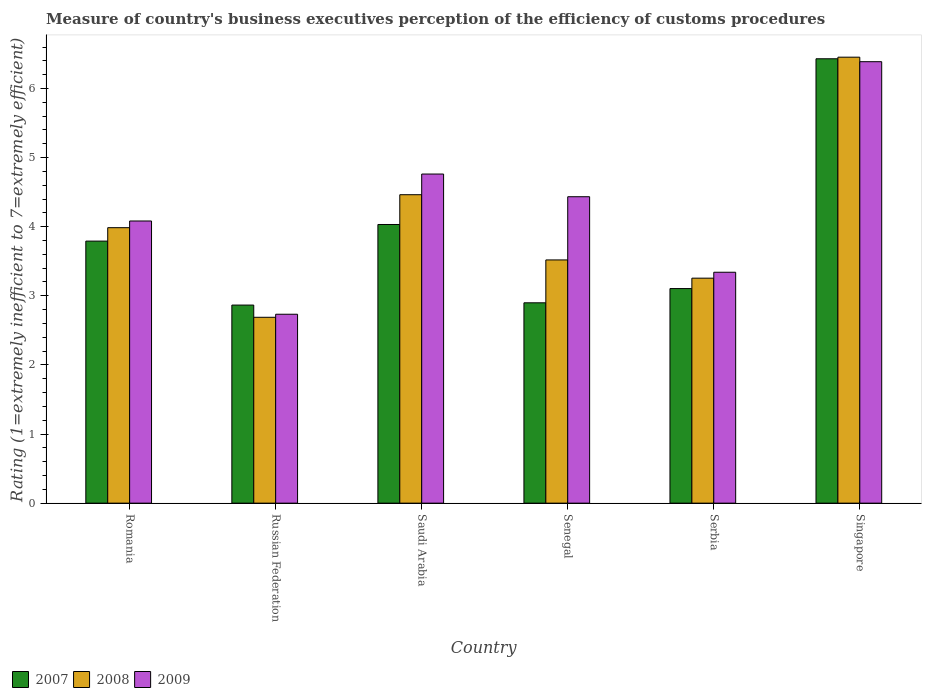Are the number of bars on each tick of the X-axis equal?
Ensure brevity in your answer.  Yes. How many bars are there on the 6th tick from the left?
Offer a very short reply. 3. What is the label of the 6th group of bars from the left?
Ensure brevity in your answer.  Singapore. In how many cases, is the number of bars for a given country not equal to the number of legend labels?
Your answer should be compact. 0. What is the rating of the efficiency of customs procedure in 2009 in Russian Federation?
Ensure brevity in your answer.  2.73. Across all countries, what is the maximum rating of the efficiency of customs procedure in 2008?
Make the answer very short. 6.45. Across all countries, what is the minimum rating of the efficiency of customs procedure in 2007?
Make the answer very short. 2.87. In which country was the rating of the efficiency of customs procedure in 2009 maximum?
Keep it short and to the point. Singapore. In which country was the rating of the efficiency of customs procedure in 2009 minimum?
Keep it short and to the point. Russian Federation. What is the total rating of the efficiency of customs procedure in 2007 in the graph?
Keep it short and to the point. 23.12. What is the difference between the rating of the efficiency of customs procedure in 2007 in Saudi Arabia and that in Senegal?
Provide a succinct answer. 1.13. What is the difference between the rating of the efficiency of customs procedure in 2008 in Romania and the rating of the efficiency of customs procedure in 2009 in Singapore?
Provide a short and direct response. -2.4. What is the average rating of the efficiency of customs procedure in 2007 per country?
Make the answer very short. 3.85. What is the difference between the rating of the efficiency of customs procedure of/in 2009 and rating of the efficiency of customs procedure of/in 2008 in Serbia?
Ensure brevity in your answer.  0.09. What is the ratio of the rating of the efficiency of customs procedure in 2009 in Russian Federation to that in Serbia?
Your answer should be compact. 0.82. Is the rating of the efficiency of customs procedure in 2009 in Romania less than that in Senegal?
Your answer should be very brief. Yes. Is the difference between the rating of the efficiency of customs procedure in 2009 in Senegal and Serbia greater than the difference between the rating of the efficiency of customs procedure in 2008 in Senegal and Serbia?
Offer a terse response. Yes. What is the difference between the highest and the second highest rating of the efficiency of customs procedure in 2009?
Offer a terse response. 0.33. What is the difference between the highest and the lowest rating of the efficiency of customs procedure in 2007?
Make the answer very short. 3.56. Is the sum of the rating of the efficiency of customs procedure in 2007 in Saudi Arabia and Senegal greater than the maximum rating of the efficiency of customs procedure in 2008 across all countries?
Your answer should be compact. Yes. Is it the case that in every country, the sum of the rating of the efficiency of customs procedure in 2008 and rating of the efficiency of customs procedure in 2009 is greater than the rating of the efficiency of customs procedure in 2007?
Ensure brevity in your answer.  Yes. How many bars are there?
Your response must be concise. 18. What is the difference between two consecutive major ticks on the Y-axis?
Your answer should be compact. 1. Are the values on the major ticks of Y-axis written in scientific E-notation?
Provide a short and direct response. No. Does the graph contain grids?
Make the answer very short. No. How many legend labels are there?
Your answer should be compact. 3. What is the title of the graph?
Offer a terse response. Measure of country's business executives perception of the efficiency of customs procedures. Does "1991" appear as one of the legend labels in the graph?
Provide a short and direct response. No. What is the label or title of the Y-axis?
Provide a succinct answer. Rating (1=extremely inefficient to 7=extremely efficient). What is the Rating (1=extremely inefficient to 7=extremely efficient) of 2007 in Romania?
Offer a terse response. 3.79. What is the Rating (1=extremely inefficient to 7=extremely efficient) of 2008 in Romania?
Keep it short and to the point. 3.99. What is the Rating (1=extremely inefficient to 7=extremely efficient) of 2009 in Romania?
Your answer should be compact. 4.08. What is the Rating (1=extremely inefficient to 7=extremely efficient) of 2007 in Russian Federation?
Your answer should be compact. 2.87. What is the Rating (1=extremely inefficient to 7=extremely efficient) in 2008 in Russian Federation?
Keep it short and to the point. 2.69. What is the Rating (1=extremely inefficient to 7=extremely efficient) in 2009 in Russian Federation?
Your answer should be compact. 2.73. What is the Rating (1=extremely inefficient to 7=extremely efficient) of 2007 in Saudi Arabia?
Your response must be concise. 4.03. What is the Rating (1=extremely inefficient to 7=extremely efficient) in 2008 in Saudi Arabia?
Your response must be concise. 4.46. What is the Rating (1=extremely inefficient to 7=extremely efficient) in 2009 in Saudi Arabia?
Give a very brief answer. 4.76. What is the Rating (1=extremely inefficient to 7=extremely efficient) in 2007 in Senegal?
Make the answer very short. 2.9. What is the Rating (1=extremely inefficient to 7=extremely efficient) of 2008 in Senegal?
Ensure brevity in your answer.  3.52. What is the Rating (1=extremely inefficient to 7=extremely efficient) of 2009 in Senegal?
Offer a terse response. 4.43. What is the Rating (1=extremely inefficient to 7=extremely efficient) in 2007 in Serbia?
Provide a succinct answer. 3.1. What is the Rating (1=extremely inefficient to 7=extremely efficient) of 2008 in Serbia?
Provide a short and direct response. 3.26. What is the Rating (1=extremely inefficient to 7=extremely efficient) in 2009 in Serbia?
Your answer should be compact. 3.34. What is the Rating (1=extremely inefficient to 7=extremely efficient) of 2007 in Singapore?
Give a very brief answer. 6.43. What is the Rating (1=extremely inefficient to 7=extremely efficient) of 2008 in Singapore?
Make the answer very short. 6.45. What is the Rating (1=extremely inefficient to 7=extremely efficient) in 2009 in Singapore?
Your response must be concise. 6.39. Across all countries, what is the maximum Rating (1=extremely inefficient to 7=extremely efficient) of 2007?
Provide a succinct answer. 6.43. Across all countries, what is the maximum Rating (1=extremely inefficient to 7=extremely efficient) in 2008?
Ensure brevity in your answer.  6.45. Across all countries, what is the maximum Rating (1=extremely inefficient to 7=extremely efficient) in 2009?
Provide a short and direct response. 6.39. Across all countries, what is the minimum Rating (1=extremely inefficient to 7=extremely efficient) in 2007?
Provide a short and direct response. 2.87. Across all countries, what is the minimum Rating (1=extremely inefficient to 7=extremely efficient) of 2008?
Your response must be concise. 2.69. Across all countries, what is the minimum Rating (1=extremely inefficient to 7=extremely efficient) of 2009?
Offer a terse response. 2.73. What is the total Rating (1=extremely inefficient to 7=extremely efficient) of 2007 in the graph?
Give a very brief answer. 23.12. What is the total Rating (1=extremely inefficient to 7=extremely efficient) in 2008 in the graph?
Your answer should be compact. 24.37. What is the total Rating (1=extremely inefficient to 7=extremely efficient) of 2009 in the graph?
Provide a succinct answer. 25.74. What is the difference between the Rating (1=extremely inefficient to 7=extremely efficient) of 2007 in Romania and that in Russian Federation?
Your answer should be compact. 0.93. What is the difference between the Rating (1=extremely inefficient to 7=extremely efficient) of 2008 in Romania and that in Russian Federation?
Your answer should be compact. 1.3. What is the difference between the Rating (1=extremely inefficient to 7=extremely efficient) of 2009 in Romania and that in Russian Federation?
Provide a short and direct response. 1.35. What is the difference between the Rating (1=extremely inefficient to 7=extremely efficient) of 2007 in Romania and that in Saudi Arabia?
Keep it short and to the point. -0.24. What is the difference between the Rating (1=extremely inefficient to 7=extremely efficient) of 2008 in Romania and that in Saudi Arabia?
Give a very brief answer. -0.48. What is the difference between the Rating (1=extremely inefficient to 7=extremely efficient) in 2009 in Romania and that in Saudi Arabia?
Make the answer very short. -0.68. What is the difference between the Rating (1=extremely inefficient to 7=extremely efficient) of 2007 in Romania and that in Senegal?
Your answer should be compact. 0.89. What is the difference between the Rating (1=extremely inefficient to 7=extremely efficient) of 2008 in Romania and that in Senegal?
Offer a very short reply. 0.47. What is the difference between the Rating (1=extremely inefficient to 7=extremely efficient) of 2009 in Romania and that in Senegal?
Your response must be concise. -0.35. What is the difference between the Rating (1=extremely inefficient to 7=extremely efficient) of 2007 in Romania and that in Serbia?
Make the answer very short. 0.69. What is the difference between the Rating (1=extremely inefficient to 7=extremely efficient) in 2008 in Romania and that in Serbia?
Offer a very short reply. 0.73. What is the difference between the Rating (1=extremely inefficient to 7=extremely efficient) of 2009 in Romania and that in Serbia?
Your answer should be compact. 0.74. What is the difference between the Rating (1=extremely inefficient to 7=extremely efficient) of 2007 in Romania and that in Singapore?
Ensure brevity in your answer.  -2.64. What is the difference between the Rating (1=extremely inefficient to 7=extremely efficient) in 2008 in Romania and that in Singapore?
Provide a short and direct response. -2.47. What is the difference between the Rating (1=extremely inefficient to 7=extremely efficient) in 2009 in Romania and that in Singapore?
Keep it short and to the point. -2.3. What is the difference between the Rating (1=extremely inefficient to 7=extremely efficient) in 2007 in Russian Federation and that in Saudi Arabia?
Your answer should be very brief. -1.17. What is the difference between the Rating (1=extremely inefficient to 7=extremely efficient) of 2008 in Russian Federation and that in Saudi Arabia?
Keep it short and to the point. -1.77. What is the difference between the Rating (1=extremely inefficient to 7=extremely efficient) of 2009 in Russian Federation and that in Saudi Arabia?
Provide a short and direct response. -2.03. What is the difference between the Rating (1=extremely inefficient to 7=extremely efficient) in 2007 in Russian Federation and that in Senegal?
Your answer should be very brief. -0.03. What is the difference between the Rating (1=extremely inefficient to 7=extremely efficient) of 2008 in Russian Federation and that in Senegal?
Your answer should be very brief. -0.83. What is the difference between the Rating (1=extremely inefficient to 7=extremely efficient) in 2009 in Russian Federation and that in Senegal?
Your answer should be very brief. -1.7. What is the difference between the Rating (1=extremely inefficient to 7=extremely efficient) in 2007 in Russian Federation and that in Serbia?
Offer a very short reply. -0.24. What is the difference between the Rating (1=extremely inefficient to 7=extremely efficient) in 2008 in Russian Federation and that in Serbia?
Give a very brief answer. -0.57. What is the difference between the Rating (1=extremely inefficient to 7=extremely efficient) in 2009 in Russian Federation and that in Serbia?
Offer a very short reply. -0.61. What is the difference between the Rating (1=extremely inefficient to 7=extremely efficient) in 2007 in Russian Federation and that in Singapore?
Provide a short and direct response. -3.56. What is the difference between the Rating (1=extremely inefficient to 7=extremely efficient) of 2008 in Russian Federation and that in Singapore?
Offer a very short reply. -3.76. What is the difference between the Rating (1=extremely inefficient to 7=extremely efficient) of 2009 in Russian Federation and that in Singapore?
Give a very brief answer. -3.65. What is the difference between the Rating (1=extremely inefficient to 7=extremely efficient) of 2007 in Saudi Arabia and that in Senegal?
Provide a short and direct response. 1.13. What is the difference between the Rating (1=extremely inefficient to 7=extremely efficient) of 2008 in Saudi Arabia and that in Senegal?
Provide a succinct answer. 0.94. What is the difference between the Rating (1=extremely inefficient to 7=extremely efficient) in 2009 in Saudi Arabia and that in Senegal?
Your answer should be very brief. 0.33. What is the difference between the Rating (1=extremely inefficient to 7=extremely efficient) of 2007 in Saudi Arabia and that in Serbia?
Provide a succinct answer. 0.93. What is the difference between the Rating (1=extremely inefficient to 7=extremely efficient) in 2008 in Saudi Arabia and that in Serbia?
Keep it short and to the point. 1.21. What is the difference between the Rating (1=extremely inefficient to 7=extremely efficient) in 2009 in Saudi Arabia and that in Serbia?
Provide a succinct answer. 1.42. What is the difference between the Rating (1=extremely inefficient to 7=extremely efficient) of 2007 in Saudi Arabia and that in Singapore?
Make the answer very short. -2.4. What is the difference between the Rating (1=extremely inefficient to 7=extremely efficient) in 2008 in Saudi Arabia and that in Singapore?
Provide a short and direct response. -1.99. What is the difference between the Rating (1=extremely inefficient to 7=extremely efficient) of 2009 in Saudi Arabia and that in Singapore?
Your answer should be compact. -1.63. What is the difference between the Rating (1=extremely inefficient to 7=extremely efficient) of 2007 in Senegal and that in Serbia?
Ensure brevity in your answer.  -0.21. What is the difference between the Rating (1=extremely inefficient to 7=extremely efficient) of 2008 in Senegal and that in Serbia?
Provide a succinct answer. 0.26. What is the difference between the Rating (1=extremely inefficient to 7=extremely efficient) of 2009 in Senegal and that in Serbia?
Your answer should be compact. 1.09. What is the difference between the Rating (1=extremely inefficient to 7=extremely efficient) in 2007 in Senegal and that in Singapore?
Your response must be concise. -3.53. What is the difference between the Rating (1=extremely inefficient to 7=extremely efficient) in 2008 in Senegal and that in Singapore?
Provide a short and direct response. -2.93. What is the difference between the Rating (1=extremely inefficient to 7=extremely efficient) of 2009 in Senegal and that in Singapore?
Ensure brevity in your answer.  -1.95. What is the difference between the Rating (1=extremely inefficient to 7=extremely efficient) in 2007 in Serbia and that in Singapore?
Make the answer very short. -3.33. What is the difference between the Rating (1=extremely inefficient to 7=extremely efficient) in 2008 in Serbia and that in Singapore?
Provide a short and direct response. -3.2. What is the difference between the Rating (1=extremely inefficient to 7=extremely efficient) of 2009 in Serbia and that in Singapore?
Offer a very short reply. -3.05. What is the difference between the Rating (1=extremely inefficient to 7=extremely efficient) in 2007 in Romania and the Rating (1=extremely inefficient to 7=extremely efficient) in 2008 in Russian Federation?
Offer a very short reply. 1.1. What is the difference between the Rating (1=extremely inefficient to 7=extremely efficient) in 2007 in Romania and the Rating (1=extremely inefficient to 7=extremely efficient) in 2009 in Russian Federation?
Your response must be concise. 1.06. What is the difference between the Rating (1=extremely inefficient to 7=extremely efficient) in 2008 in Romania and the Rating (1=extremely inefficient to 7=extremely efficient) in 2009 in Russian Federation?
Keep it short and to the point. 1.25. What is the difference between the Rating (1=extremely inefficient to 7=extremely efficient) in 2007 in Romania and the Rating (1=extremely inefficient to 7=extremely efficient) in 2008 in Saudi Arabia?
Keep it short and to the point. -0.67. What is the difference between the Rating (1=extremely inefficient to 7=extremely efficient) in 2007 in Romania and the Rating (1=extremely inefficient to 7=extremely efficient) in 2009 in Saudi Arabia?
Give a very brief answer. -0.97. What is the difference between the Rating (1=extremely inefficient to 7=extremely efficient) of 2008 in Romania and the Rating (1=extremely inefficient to 7=extremely efficient) of 2009 in Saudi Arabia?
Ensure brevity in your answer.  -0.78. What is the difference between the Rating (1=extremely inefficient to 7=extremely efficient) of 2007 in Romania and the Rating (1=extremely inefficient to 7=extremely efficient) of 2008 in Senegal?
Keep it short and to the point. 0.27. What is the difference between the Rating (1=extremely inefficient to 7=extremely efficient) of 2007 in Romania and the Rating (1=extremely inefficient to 7=extremely efficient) of 2009 in Senegal?
Provide a succinct answer. -0.64. What is the difference between the Rating (1=extremely inefficient to 7=extremely efficient) of 2008 in Romania and the Rating (1=extremely inefficient to 7=extremely efficient) of 2009 in Senegal?
Offer a very short reply. -0.45. What is the difference between the Rating (1=extremely inefficient to 7=extremely efficient) in 2007 in Romania and the Rating (1=extremely inefficient to 7=extremely efficient) in 2008 in Serbia?
Offer a terse response. 0.54. What is the difference between the Rating (1=extremely inefficient to 7=extremely efficient) of 2007 in Romania and the Rating (1=extremely inefficient to 7=extremely efficient) of 2009 in Serbia?
Provide a succinct answer. 0.45. What is the difference between the Rating (1=extremely inefficient to 7=extremely efficient) in 2008 in Romania and the Rating (1=extremely inefficient to 7=extremely efficient) in 2009 in Serbia?
Offer a terse response. 0.64. What is the difference between the Rating (1=extremely inefficient to 7=extremely efficient) of 2007 in Romania and the Rating (1=extremely inefficient to 7=extremely efficient) of 2008 in Singapore?
Your response must be concise. -2.66. What is the difference between the Rating (1=extremely inefficient to 7=extremely efficient) in 2007 in Romania and the Rating (1=extremely inefficient to 7=extremely efficient) in 2009 in Singapore?
Keep it short and to the point. -2.6. What is the difference between the Rating (1=extremely inefficient to 7=extremely efficient) of 2008 in Romania and the Rating (1=extremely inefficient to 7=extremely efficient) of 2009 in Singapore?
Your response must be concise. -2.4. What is the difference between the Rating (1=extremely inefficient to 7=extremely efficient) in 2007 in Russian Federation and the Rating (1=extremely inefficient to 7=extremely efficient) in 2008 in Saudi Arabia?
Keep it short and to the point. -1.6. What is the difference between the Rating (1=extremely inefficient to 7=extremely efficient) of 2007 in Russian Federation and the Rating (1=extremely inefficient to 7=extremely efficient) of 2009 in Saudi Arabia?
Your answer should be very brief. -1.9. What is the difference between the Rating (1=extremely inefficient to 7=extremely efficient) of 2008 in Russian Federation and the Rating (1=extremely inefficient to 7=extremely efficient) of 2009 in Saudi Arabia?
Offer a very short reply. -2.07. What is the difference between the Rating (1=extremely inefficient to 7=extremely efficient) in 2007 in Russian Federation and the Rating (1=extremely inefficient to 7=extremely efficient) in 2008 in Senegal?
Provide a succinct answer. -0.65. What is the difference between the Rating (1=extremely inefficient to 7=extremely efficient) of 2007 in Russian Federation and the Rating (1=extremely inefficient to 7=extremely efficient) of 2009 in Senegal?
Offer a very short reply. -1.57. What is the difference between the Rating (1=extremely inefficient to 7=extremely efficient) in 2008 in Russian Federation and the Rating (1=extremely inefficient to 7=extremely efficient) in 2009 in Senegal?
Ensure brevity in your answer.  -1.74. What is the difference between the Rating (1=extremely inefficient to 7=extremely efficient) of 2007 in Russian Federation and the Rating (1=extremely inefficient to 7=extremely efficient) of 2008 in Serbia?
Your response must be concise. -0.39. What is the difference between the Rating (1=extremely inefficient to 7=extremely efficient) of 2007 in Russian Federation and the Rating (1=extremely inefficient to 7=extremely efficient) of 2009 in Serbia?
Offer a very short reply. -0.48. What is the difference between the Rating (1=extremely inefficient to 7=extremely efficient) of 2008 in Russian Federation and the Rating (1=extremely inefficient to 7=extremely efficient) of 2009 in Serbia?
Keep it short and to the point. -0.65. What is the difference between the Rating (1=extremely inefficient to 7=extremely efficient) in 2007 in Russian Federation and the Rating (1=extremely inefficient to 7=extremely efficient) in 2008 in Singapore?
Make the answer very short. -3.59. What is the difference between the Rating (1=extremely inefficient to 7=extremely efficient) in 2007 in Russian Federation and the Rating (1=extremely inefficient to 7=extremely efficient) in 2009 in Singapore?
Give a very brief answer. -3.52. What is the difference between the Rating (1=extremely inefficient to 7=extremely efficient) in 2008 in Russian Federation and the Rating (1=extremely inefficient to 7=extremely efficient) in 2009 in Singapore?
Offer a very short reply. -3.7. What is the difference between the Rating (1=extremely inefficient to 7=extremely efficient) of 2007 in Saudi Arabia and the Rating (1=extremely inefficient to 7=extremely efficient) of 2008 in Senegal?
Your answer should be very brief. 0.51. What is the difference between the Rating (1=extremely inefficient to 7=extremely efficient) in 2007 in Saudi Arabia and the Rating (1=extremely inefficient to 7=extremely efficient) in 2009 in Senegal?
Your response must be concise. -0.4. What is the difference between the Rating (1=extremely inefficient to 7=extremely efficient) of 2008 in Saudi Arabia and the Rating (1=extremely inefficient to 7=extremely efficient) of 2009 in Senegal?
Provide a succinct answer. 0.03. What is the difference between the Rating (1=extremely inefficient to 7=extremely efficient) in 2007 in Saudi Arabia and the Rating (1=extremely inefficient to 7=extremely efficient) in 2008 in Serbia?
Give a very brief answer. 0.78. What is the difference between the Rating (1=extremely inefficient to 7=extremely efficient) of 2007 in Saudi Arabia and the Rating (1=extremely inefficient to 7=extremely efficient) of 2009 in Serbia?
Your answer should be compact. 0.69. What is the difference between the Rating (1=extremely inefficient to 7=extremely efficient) in 2008 in Saudi Arabia and the Rating (1=extremely inefficient to 7=extremely efficient) in 2009 in Serbia?
Keep it short and to the point. 1.12. What is the difference between the Rating (1=extremely inefficient to 7=extremely efficient) of 2007 in Saudi Arabia and the Rating (1=extremely inefficient to 7=extremely efficient) of 2008 in Singapore?
Provide a short and direct response. -2.42. What is the difference between the Rating (1=extremely inefficient to 7=extremely efficient) in 2007 in Saudi Arabia and the Rating (1=extremely inefficient to 7=extremely efficient) in 2009 in Singapore?
Provide a succinct answer. -2.36. What is the difference between the Rating (1=extremely inefficient to 7=extremely efficient) of 2008 in Saudi Arabia and the Rating (1=extremely inefficient to 7=extremely efficient) of 2009 in Singapore?
Offer a terse response. -1.92. What is the difference between the Rating (1=extremely inefficient to 7=extremely efficient) in 2007 in Senegal and the Rating (1=extremely inefficient to 7=extremely efficient) in 2008 in Serbia?
Your answer should be compact. -0.36. What is the difference between the Rating (1=extremely inefficient to 7=extremely efficient) in 2007 in Senegal and the Rating (1=extremely inefficient to 7=extremely efficient) in 2009 in Serbia?
Provide a short and direct response. -0.44. What is the difference between the Rating (1=extremely inefficient to 7=extremely efficient) in 2008 in Senegal and the Rating (1=extremely inefficient to 7=extremely efficient) in 2009 in Serbia?
Keep it short and to the point. 0.18. What is the difference between the Rating (1=extremely inefficient to 7=extremely efficient) of 2007 in Senegal and the Rating (1=extremely inefficient to 7=extremely efficient) of 2008 in Singapore?
Offer a terse response. -3.55. What is the difference between the Rating (1=extremely inefficient to 7=extremely efficient) of 2007 in Senegal and the Rating (1=extremely inefficient to 7=extremely efficient) of 2009 in Singapore?
Ensure brevity in your answer.  -3.49. What is the difference between the Rating (1=extremely inefficient to 7=extremely efficient) in 2008 in Senegal and the Rating (1=extremely inefficient to 7=extremely efficient) in 2009 in Singapore?
Give a very brief answer. -2.87. What is the difference between the Rating (1=extremely inefficient to 7=extremely efficient) in 2007 in Serbia and the Rating (1=extremely inefficient to 7=extremely efficient) in 2008 in Singapore?
Ensure brevity in your answer.  -3.35. What is the difference between the Rating (1=extremely inefficient to 7=extremely efficient) in 2007 in Serbia and the Rating (1=extremely inefficient to 7=extremely efficient) in 2009 in Singapore?
Your answer should be very brief. -3.28. What is the difference between the Rating (1=extremely inefficient to 7=extremely efficient) of 2008 in Serbia and the Rating (1=extremely inefficient to 7=extremely efficient) of 2009 in Singapore?
Make the answer very short. -3.13. What is the average Rating (1=extremely inefficient to 7=extremely efficient) of 2007 per country?
Offer a terse response. 3.85. What is the average Rating (1=extremely inefficient to 7=extremely efficient) in 2008 per country?
Ensure brevity in your answer.  4.06. What is the average Rating (1=extremely inefficient to 7=extremely efficient) in 2009 per country?
Make the answer very short. 4.29. What is the difference between the Rating (1=extremely inefficient to 7=extremely efficient) in 2007 and Rating (1=extremely inefficient to 7=extremely efficient) in 2008 in Romania?
Give a very brief answer. -0.19. What is the difference between the Rating (1=extremely inefficient to 7=extremely efficient) in 2007 and Rating (1=extremely inefficient to 7=extremely efficient) in 2009 in Romania?
Your response must be concise. -0.29. What is the difference between the Rating (1=extremely inefficient to 7=extremely efficient) of 2008 and Rating (1=extremely inefficient to 7=extremely efficient) of 2009 in Romania?
Provide a succinct answer. -0.1. What is the difference between the Rating (1=extremely inefficient to 7=extremely efficient) of 2007 and Rating (1=extremely inefficient to 7=extremely efficient) of 2008 in Russian Federation?
Your answer should be very brief. 0.18. What is the difference between the Rating (1=extremely inefficient to 7=extremely efficient) of 2007 and Rating (1=extremely inefficient to 7=extremely efficient) of 2009 in Russian Federation?
Provide a succinct answer. 0.13. What is the difference between the Rating (1=extremely inefficient to 7=extremely efficient) of 2008 and Rating (1=extremely inefficient to 7=extremely efficient) of 2009 in Russian Federation?
Ensure brevity in your answer.  -0.04. What is the difference between the Rating (1=extremely inefficient to 7=extremely efficient) of 2007 and Rating (1=extremely inefficient to 7=extremely efficient) of 2008 in Saudi Arabia?
Offer a terse response. -0.43. What is the difference between the Rating (1=extremely inefficient to 7=extremely efficient) in 2007 and Rating (1=extremely inefficient to 7=extremely efficient) in 2009 in Saudi Arabia?
Your response must be concise. -0.73. What is the difference between the Rating (1=extremely inefficient to 7=extremely efficient) in 2008 and Rating (1=extremely inefficient to 7=extremely efficient) in 2009 in Saudi Arabia?
Your answer should be very brief. -0.3. What is the difference between the Rating (1=extremely inefficient to 7=extremely efficient) of 2007 and Rating (1=extremely inefficient to 7=extremely efficient) of 2008 in Senegal?
Provide a succinct answer. -0.62. What is the difference between the Rating (1=extremely inefficient to 7=extremely efficient) in 2007 and Rating (1=extremely inefficient to 7=extremely efficient) in 2009 in Senegal?
Keep it short and to the point. -1.53. What is the difference between the Rating (1=extremely inefficient to 7=extremely efficient) of 2008 and Rating (1=extremely inefficient to 7=extremely efficient) of 2009 in Senegal?
Give a very brief answer. -0.91. What is the difference between the Rating (1=extremely inefficient to 7=extremely efficient) in 2007 and Rating (1=extremely inefficient to 7=extremely efficient) in 2008 in Serbia?
Give a very brief answer. -0.15. What is the difference between the Rating (1=extremely inefficient to 7=extremely efficient) of 2007 and Rating (1=extremely inefficient to 7=extremely efficient) of 2009 in Serbia?
Give a very brief answer. -0.24. What is the difference between the Rating (1=extremely inefficient to 7=extremely efficient) of 2008 and Rating (1=extremely inefficient to 7=extremely efficient) of 2009 in Serbia?
Provide a succinct answer. -0.09. What is the difference between the Rating (1=extremely inefficient to 7=extremely efficient) of 2007 and Rating (1=extremely inefficient to 7=extremely efficient) of 2008 in Singapore?
Provide a succinct answer. -0.02. What is the difference between the Rating (1=extremely inefficient to 7=extremely efficient) in 2007 and Rating (1=extremely inefficient to 7=extremely efficient) in 2009 in Singapore?
Provide a succinct answer. 0.04. What is the difference between the Rating (1=extremely inefficient to 7=extremely efficient) of 2008 and Rating (1=extremely inefficient to 7=extremely efficient) of 2009 in Singapore?
Make the answer very short. 0.07. What is the ratio of the Rating (1=extremely inefficient to 7=extremely efficient) in 2007 in Romania to that in Russian Federation?
Provide a succinct answer. 1.32. What is the ratio of the Rating (1=extremely inefficient to 7=extremely efficient) in 2008 in Romania to that in Russian Federation?
Offer a terse response. 1.48. What is the ratio of the Rating (1=extremely inefficient to 7=extremely efficient) in 2009 in Romania to that in Russian Federation?
Your answer should be compact. 1.49. What is the ratio of the Rating (1=extremely inefficient to 7=extremely efficient) of 2007 in Romania to that in Saudi Arabia?
Make the answer very short. 0.94. What is the ratio of the Rating (1=extremely inefficient to 7=extremely efficient) of 2008 in Romania to that in Saudi Arabia?
Your answer should be very brief. 0.89. What is the ratio of the Rating (1=extremely inefficient to 7=extremely efficient) in 2009 in Romania to that in Saudi Arabia?
Provide a succinct answer. 0.86. What is the ratio of the Rating (1=extremely inefficient to 7=extremely efficient) of 2007 in Romania to that in Senegal?
Keep it short and to the point. 1.31. What is the ratio of the Rating (1=extremely inefficient to 7=extremely efficient) in 2008 in Romania to that in Senegal?
Your answer should be compact. 1.13. What is the ratio of the Rating (1=extremely inefficient to 7=extremely efficient) in 2009 in Romania to that in Senegal?
Provide a succinct answer. 0.92. What is the ratio of the Rating (1=extremely inefficient to 7=extremely efficient) of 2007 in Romania to that in Serbia?
Offer a very short reply. 1.22. What is the ratio of the Rating (1=extremely inefficient to 7=extremely efficient) in 2008 in Romania to that in Serbia?
Provide a short and direct response. 1.22. What is the ratio of the Rating (1=extremely inefficient to 7=extremely efficient) in 2009 in Romania to that in Serbia?
Provide a succinct answer. 1.22. What is the ratio of the Rating (1=extremely inefficient to 7=extremely efficient) of 2007 in Romania to that in Singapore?
Your answer should be very brief. 0.59. What is the ratio of the Rating (1=extremely inefficient to 7=extremely efficient) in 2008 in Romania to that in Singapore?
Give a very brief answer. 0.62. What is the ratio of the Rating (1=extremely inefficient to 7=extremely efficient) of 2009 in Romania to that in Singapore?
Offer a terse response. 0.64. What is the ratio of the Rating (1=extremely inefficient to 7=extremely efficient) in 2007 in Russian Federation to that in Saudi Arabia?
Keep it short and to the point. 0.71. What is the ratio of the Rating (1=extremely inefficient to 7=extremely efficient) in 2008 in Russian Federation to that in Saudi Arabia?
Make the answer very short. 0.6. What is the ratio of the Rating (1=extremely inefficient to 7=extremely efficient) of 2009 in Russian Federation to that in Saudi Arabia?
Offer a terse response. 0.57. What is the ratio of the Rating (1=extremely inefficient to 7=extremely efficient) in 2007 in Russian Federation to that in Senegal?
Give a very brief answer. 0.99. What is the ratio of the Rating (1=extremely inefficient to 7=extremely efficient) in 2008 in Russian Federation to that in Senegal?
Ensure brevity in your answer.  0.76. What is the ratio of the Rating (1=extremely inefficient to 7=extremely efficient) of 2009 in Russian Federation to that in Senegal?
Ensure brevity in your answer.  0.62. What is the ratio of the Rating (1=extremely inefficient to 7=extremely efficient) in 2008 in Russian Federation to that in Serbia?
Keep it short and to the point. 0.83. What is the ratio of the Rating (1=extremely inefficient to 7=extremely efficient) in 2009 in Russian Federation to that in Serbia?
Provide a succinct answer. 0.82. What is the ratio of the Rating (1=extremely inefficient to 7=extremely efficient) in 2007 in Russian Federation to that in Singapore?
Your answer should be compact. 0.45. What is the ratio of the Rating (1=extremely inefficient to 7=extremely efficient) in 2008 in Russian Federation to that in Singapore?
Your answer should be very brief. 0.42. What is the ratio of the Rating (1=extremely inefficient to 7=extremely efficient) in 2009 in Russian Federation to that in Singapore?
Give a very brief answer. 0.43. What is the ratio of the Rating (1=extremely inefficient to 7=extremely efficient) in 2007 in Saudi Arabia to that in Senegal?
Give a very brief answer. 1.39. What is the ratio of the Rating (1=extremely inefficient to 7=extremely efficient) in 2008 in Saudi Arabia to that in Senegal?
Your answer should be compact. 1.27. What is the ratio of the Rating (1=extremely inefficient to 7=extremely efficient) in 2009 in Saudi Arabia to that in Senegal?
Your answer should be compact. 1.07. What is the ratio of the Rating (1=extremely inefficient to 7=extremely efficient) of 2007 in Saudi Arabia to that in Serbia?
Keep it short and to the point. 1.3. What is the ratio of the Rating (1=extremely inefficient to 7=extremely efficient) in 2008 in Saudi Arabia to that in Serbia?
Keep it short and to the point. 1.37. What is the ratio of the Rating (1=extremely inefficient to 7=extremely efficient) in 2009 in Saudi Arabia to that in Serbia?
Offer a very short reply. 1.43. What is the ratio of the Rating (1=extremely inefficient to 7=extremely efficient) of 2007 in Saudi Arabia to that in Singapore?
Ensure brevity in your answer.  0.63. What is the ratio of the Rating (1=extremely inefficient to 7=extremely efficient) of 2008 in Saudi Arabia to that in Singapore?
Offer a very short reply. 0.69. What is the ratio of the Rating (1=extremely inefficient to 7=extremely efficient) in 2009 in Saudi Arabia to that in Singapore?
Give a very brief answer. 0.75. What is the ratio of the Rating (1=extremely inefficient to 7=extremely efficient) in 2007 in Senegal to that in Serbia?
Provide a short and direct response. 0.93. What is the ratio of the Rating (1=extremely inefficient to 7=extremely efficient) of 2008 in Senegal to that in Serbia?
Provide a short and direct response. 1.08. What is the ratio of the Rating (1=extremely inefficient to 7=extremely efficient) of 2009 in Senegal to that in Serbia?
Your response must be concise. 1.33. What is the ratio of the Rating (1=extremely inefficient to 7=extremely efficient) in 2007 in Senegal to that in Singapore?
Provide a succinct answer. 0.45. What is the ratio of the Rating (1=extremely inefficient to 7=extremely efficient) in 2008 in Senegal to that in Singapore?
Your answer should be compact. 0.55. What is the ratio of the Rating (1=extremely inefficient to 7=extremely efficient) of 2009 in Senegal to that in Singapore?
Ensure brevity in your answer.  0.69. What is the ratio of the Rating (1=extremely inefficient to 7=extremely efficient) in 2007 in Serbia to that in Singapore?
Offer a terse response. 0.48. What is the ratio of the Rating (1=extremely inefficient to 7=extremely efficient) of 2008 in Serbia to that in Singapore?
Keep it short and to the point. 0.5. What is the ratio of the Rating (1=extremely inefficient to 7=extremely efficient) in 2009 in Serbia to that in Singapore?
Provide a short and direct response. 0.52. What is the difference between the highest and the second highest Rating (1=extremely inefficient to 7=extremely efficient) in 2007?
Offer a terse response. 2.4. What is the difference between the highest and the second highest Rating (1=extremely inefficient to 7=extremely efficient) of 2008?
Ensure brevity in your answer.  1.99. What is the difference between the highest and the second highest Rating (1=extremely inefficient to 7=extremely efficient) in 2009?
Provide a succinct answer. 1.63. What is the difference between the highest and the lowest Rating (1=extremely inefficient to 7=extremely efficient) of 2007?
Your response must be concise. 3.56. What is the difference between the highest and the lowest Rating (1=extremely inefficient to 7=extremely efficient) in 2008?
Give a very brief answer. 3.76. What is the difference between the highest and the lowest Rating (1=extremely inefficient to 7=extremely efficient) in 2009?
Your answer should be very brief. 3.65. 